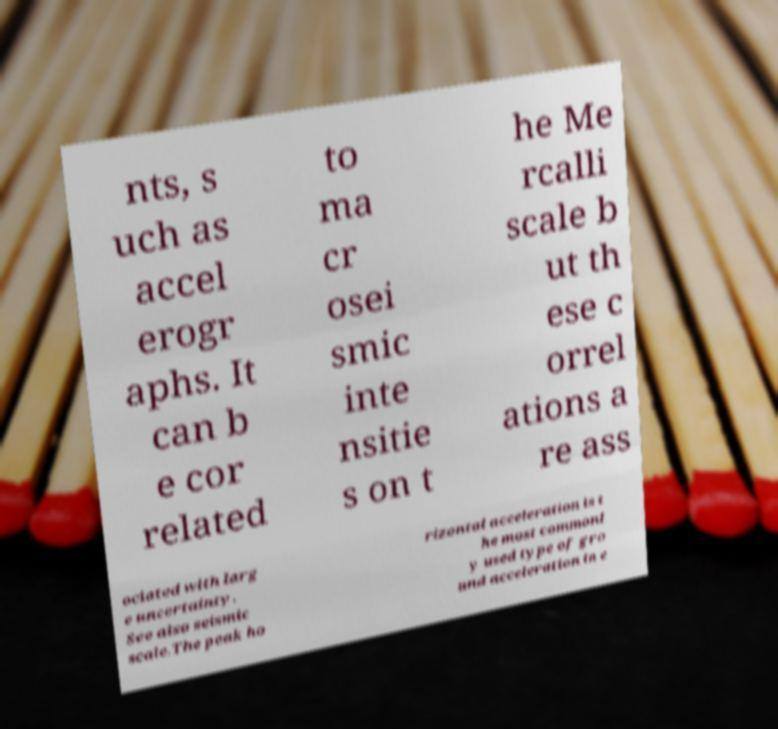Can you read and provide the text displayed in the image?This photo seems to have some interesting text. Can you extract and type it out for me? nts, s uch as accel erogr aphs. It can b e cor related to ma cr osei smic inte nsitie s on t he Me rcalli scale b ut th ese c orrel ations a re ass ociated with larg e uncertainty. See also seismic scale.The peak ho rizontal acceleration is t he most commonl y used type of gro und acceleration in e 